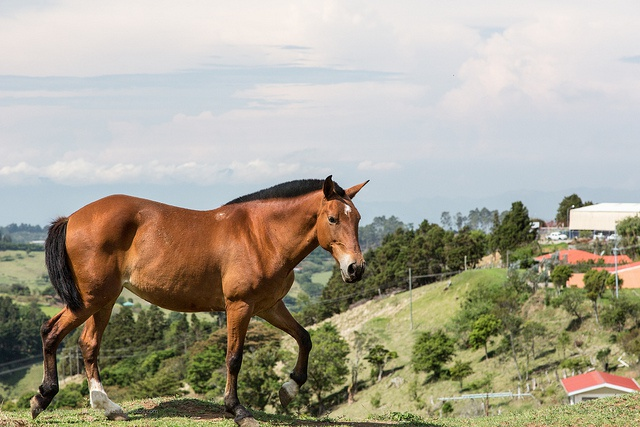Describe the objects in this image and their specific colors. I can see a horse in lightgray, black, brown, maroon, and tan tones in this image. 